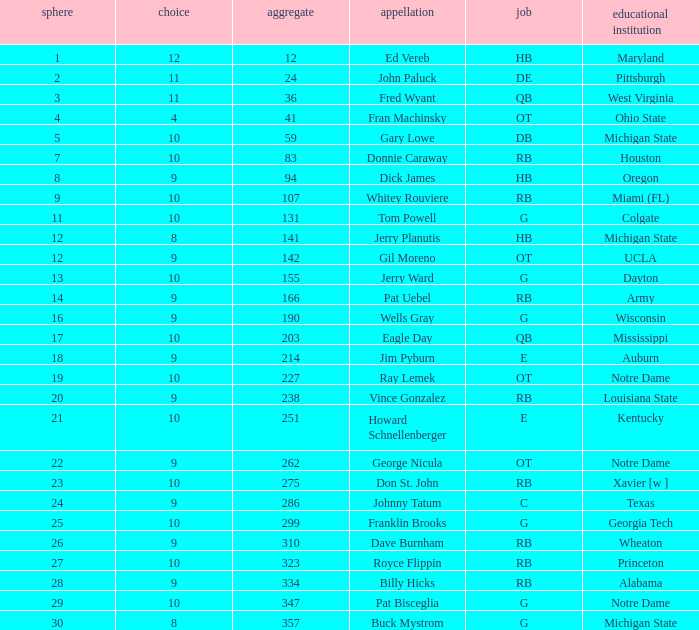What is the average number of rounds for billy hicks who had an overall pick number bigger than 310? 28.0. 